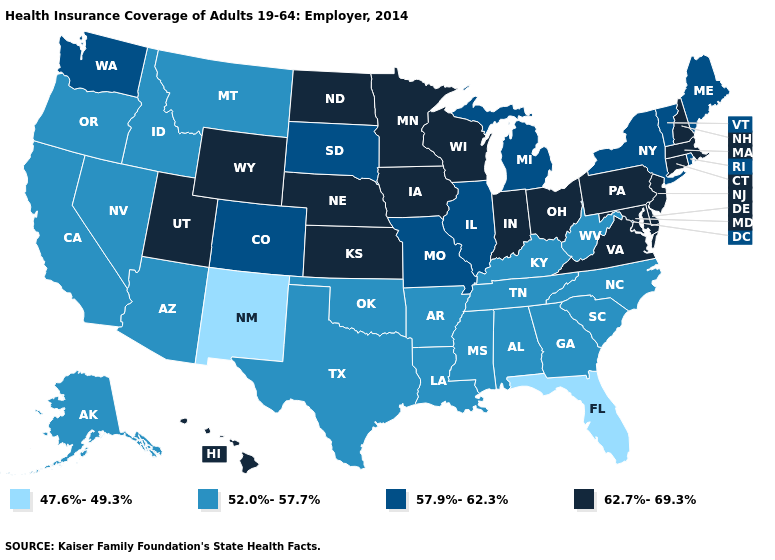Which states have the highest value in the USA?
Quick response, please. Connecticut, Delaware, Hawaii, Indiana, Iowa, Kansas, Maryland, Massachusetts, Minnesota, Nebraska, New Hampshire, New Jersey, North Dakota, Ohio, Pennsylvania, Utah, Virginia, Wisconsin, Wyoming. What is the value of Alaska?
Concise answer only. 52.0%-57.7%. What is the highest value in the MidWest ?
Give a very brief answer. 62.7%-69.3%. What is the lowest value in states that border New Jersey?
Concise answer only. 57.9%-62.3%. Does the map have missing data?
Concise answer only. No. What is the value of Iowa?
Be succinct. 62.7%-69.3%. Name the states that have a value in the range 52.0%-57.7%?
Quick response, please. Alabama, Alaska, Arizona, Arkansas, California, Georgia, Idaho, Kentucky, Louisiana, Mississippi, Montana, Nevada, North Carolina, Oklahoma, Oregon, South Carolina, Tennessee, Texas, West Virginia. Which states have the highest value in the USA?
Answer briefly. Connecticut, Delaware, Hawaii, Indiana, Iowa, Kansas, Maryland, Massachusetts, Minnesota, Nebraska, New Hampshire, New Jersey, North Dakota, Ohio, Pennsylvania, Utah, Virginia, Wisconsin, Wyoming. What is the lowest value in states that border Florida?
Give a very brief answer. 52.0%-57.7%. What is the highest value in the USA?
Concise answer only. 62.7%-69.3%. What is the value of Missouri?
Quick response, please. 57.9%-62.3%. Among the states that border New Mexico , does Colorado have the lowest value?
Keep it brief. No. Name the states that have a value in the range 47.6%-49.3%?
Quick response, please. Florida, New Mexico. Among the states that border South Carolina , which have the highest value?
Short answer required. Georgia, North Carolina. What is the lowest value in the USA?
Short answer required. 47.6%-49.3%. 